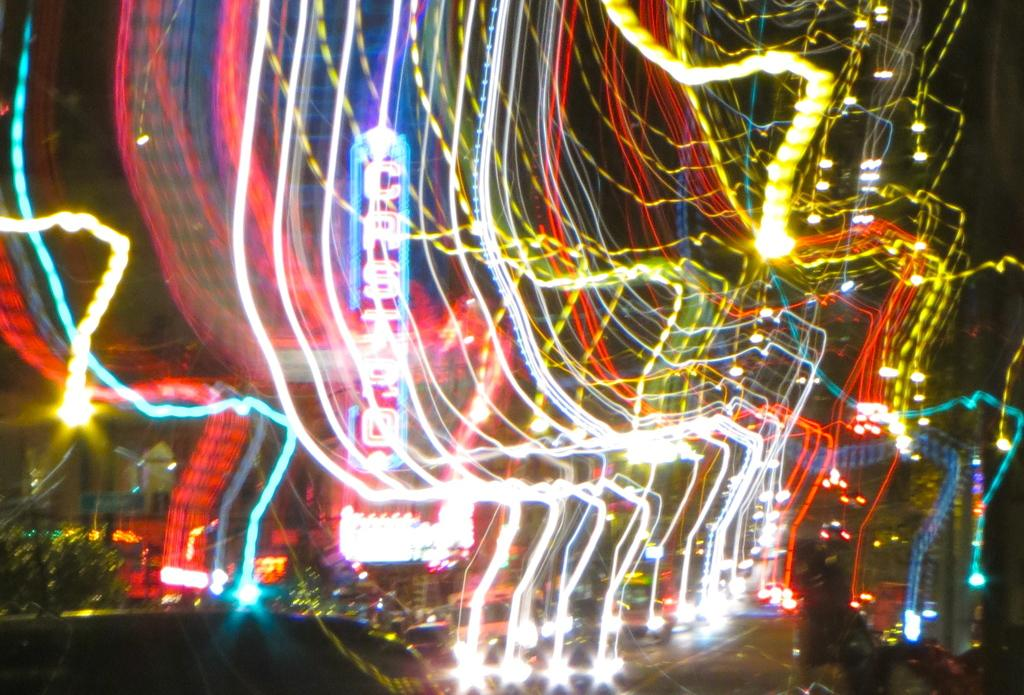What can be seen at the front of the image? There are lights in the front of the image. What is happening in the middle of the image? There are vehicles traveling on the road in the image. What is located in the background of the image? There is a hoarding in the background of the image. What type of natural scenery is visible in the background? There are trees visible in the background of the image. What is the price of the clover being sold on the hoarding in the image? There is no mention of clover or any price in the image; it features lights, vehicles, a hoarding, and trees. How many pizzas are being delivered by the vehicles in the image? There is no indication of pizzas or any delivery service in the image; it shows vehicles traveling on the road. 